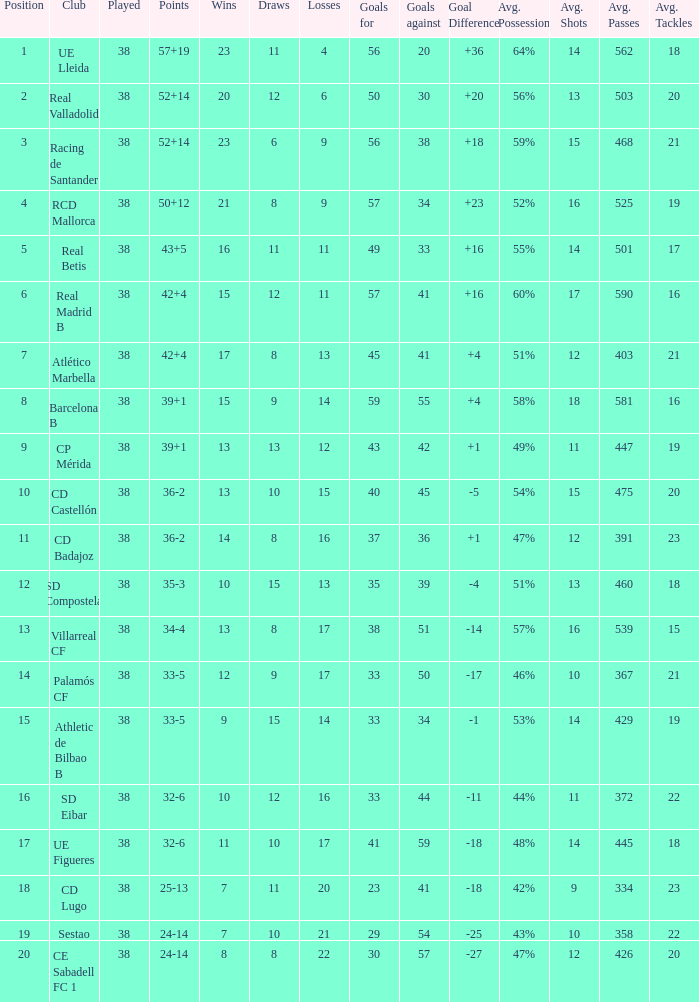What is the highest position with less than 17 losses, more than 57 goals, and a goal difference less than 4? None. 